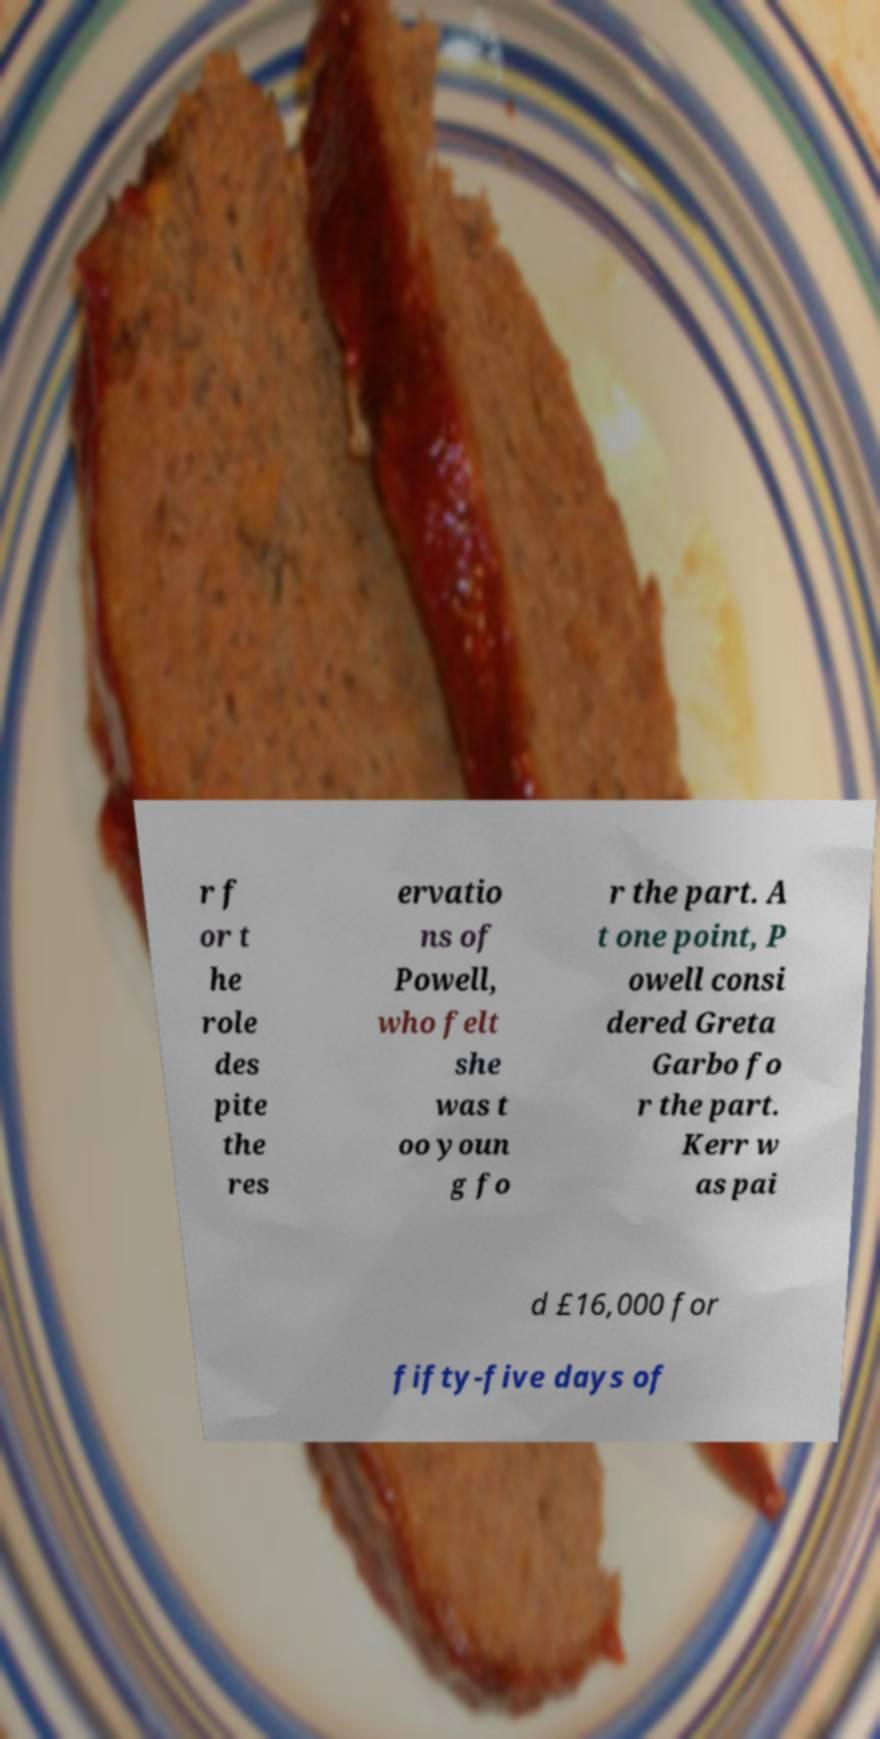Could you assist in decoding the text presented in this image and type it out clearly? r f or t he role des pite the res ervatio ns of Powell, who felt she was t oo youn g fo r the part. A t one point, P owell consi dered Greta Garbo fo r the part. Kerr w as pai d £16,000 for fifty-five days of 